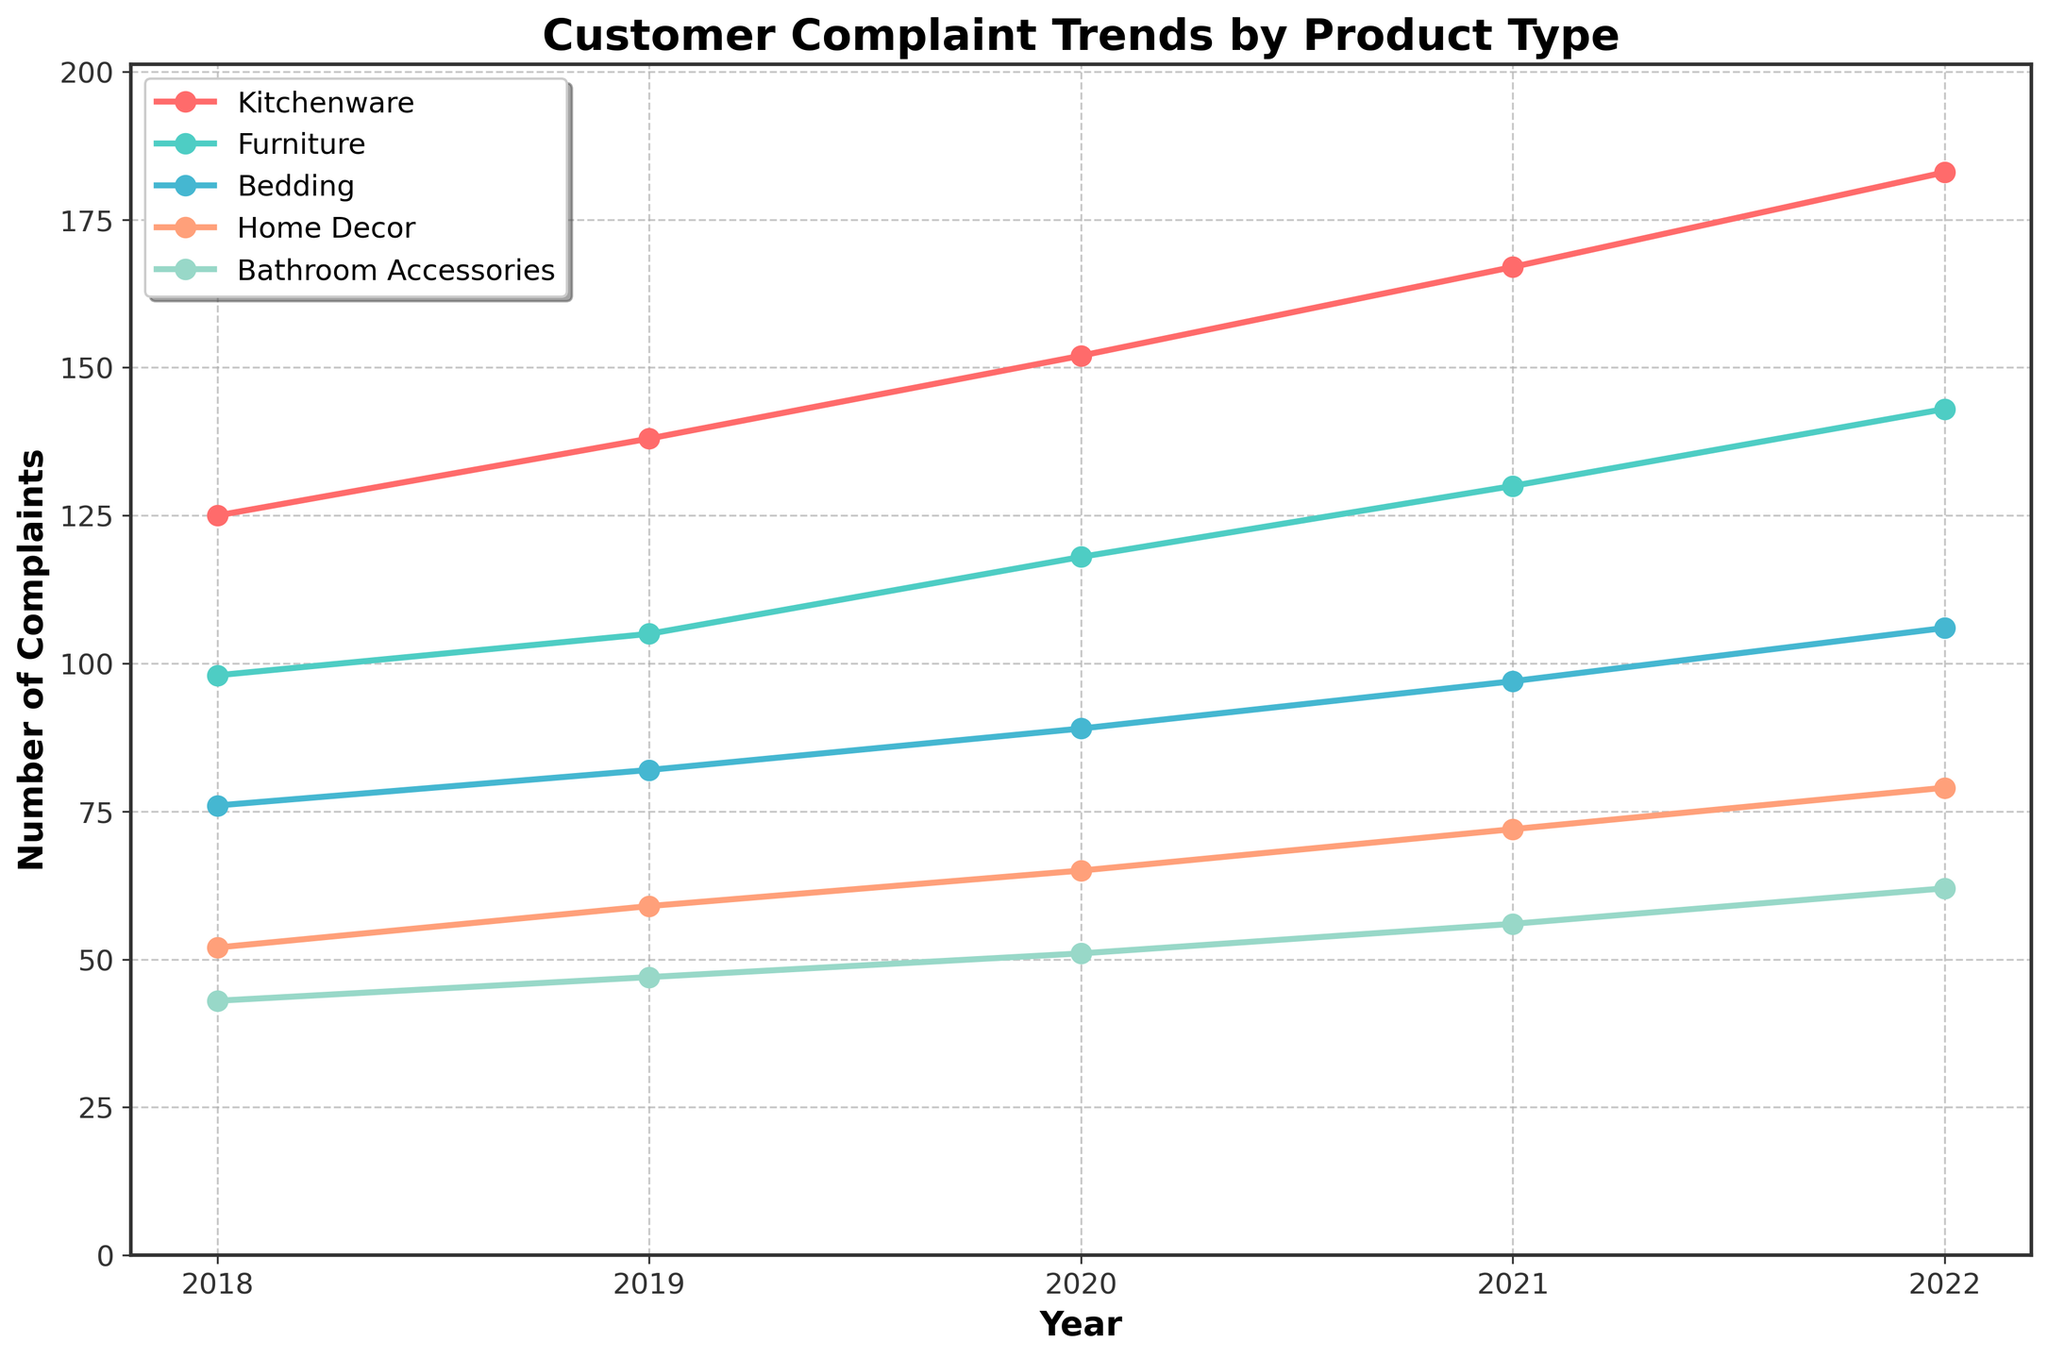What product type had the highest number of complaints in 2022? Look for the product type with the highest number of complaints in the year 2022. Compare the values for each product type in the year 2022.
Answer: Kitchenware How did complaints about Bedding change from 2019 to 2022? Subtract the number of complaints in 2019 from the number in 2022. Complaints about Bedding were 82 in 2019 and 106 in 2022.
Answer: 106 - 82 = 24 What is the total number of complaints for Home Decor over the entire 5-year period? Add the number of complaints for Home Decor for each year from 2018 to 2022. (52 + 59 + 65 + 72 + 79) = 327.
Answer: 327 Which product type had the smallest relative increase in complaints from 2018 to 2022? Calculate the difference in the number of complaints between 2018 and 2022 for each product type, and determine which has the smallest increase.
Answer: Bathroom Accessories In which year did complaints about Furniture surpass complaints about Kitchenware by the smallest margin? Calculate the differences between the number of complaints for Furniture and Kitchenware for each year. Identify the year with the smallest positive margin.
Answer: No year; Kitchenware always has more complaints than Furniture Which product type shows the most consistent yearly increase in complaints? Look for the product type with the most regular and predictable pattern of increase in the number of complaints each year from 2018 to 2022.
Answer: Kitchenware How many more complaints were made about Kitchenware than Bathroom Accessories in 2020? Subtract the number of complaints about Bathroom Accessories in 2020 from the number of complaints about Kitchenware in 2020.
Answer: 152 - 51 = 101 What is the average number of complaints in 2021 for all product types? Add the number of complaints for each product type in 2021 and divide by the total number of product types. (167 + 130 + 97 + 72 + 56) / 5 = 522 / 5 = 104.4
Answer: 104.4 